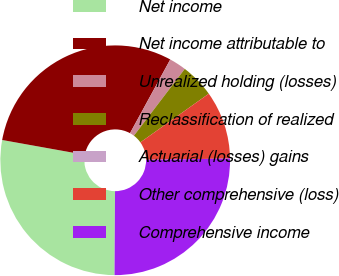Convert chart to OTSL. <chart><loc_0><loc_0><loc_500><loc_500><pie_chart><fcel>Net income<fcel>Net income attributable to<fcel>Unrealized holding (losses)<fcel>Reclassification of realized<fcel>Actuarial (losses) gains<fcel>Other comprehensive (loss)<fcel>Comprehensive income<nl><fcel>27.73%<fcel>30.13%<fcel>2.4%<fcel>4.8%<fcel>0.0%<fcel>9.6%<fcel>25.33%<nl></chart> 